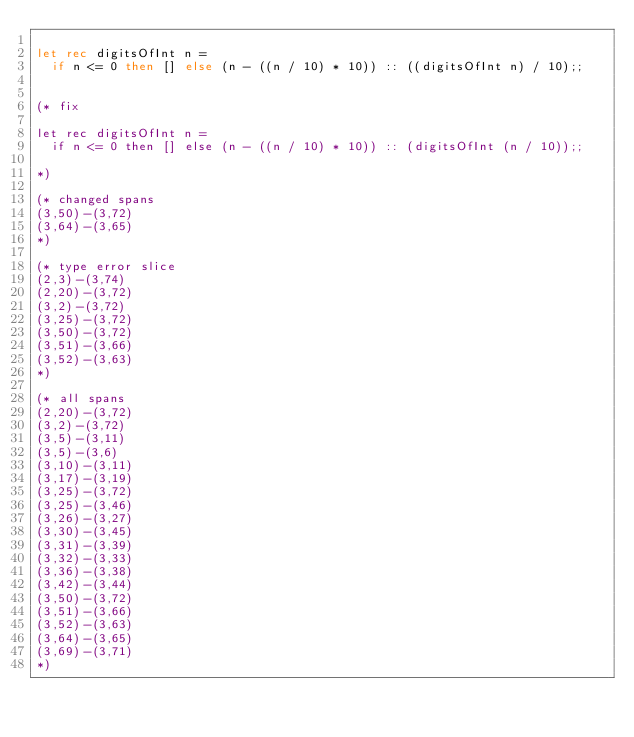<code> <loc_0><loc_0><loc_500><loc_500><_OCaml_>
let rec digitsOfInt n =
  if n <= 0 then [] else (n - ((n / 10) * 10)) :: ((digitsOfInt n) / 10);;


(* fix

let rec digitsOfInt n =
  if n <= 0 then [] else (n - ((n / 10) * 10)) :: (digitsOfInt (n / 10));;

*)

(* changed spans
(3,50)-(3,72)
(3,64)-(3,65)
*)

(* type error slice
(2,3)-(3,74)
(2,20)-(3,72)
(3,2)-(3,72)
(3,25)-(3,72)
(3,50)-(3,72)
(3,51)-(3,66)
(3,52)-(3,63)
*)

(* all spans
(2,20)-(3,72)
(3,2)-(3,72)
(3,5)-(3,11)
(3,5)-(3,6)
(3,10)-(3,11)
(3,17)-(3,19)
(3,25)-(3,72)
(3,25)-(3,46)
(3,26)-(3,27)
(3,30)-(3,45)
(3,31)-(3,39)
(3,32)-(3,33)
(3,36)-(3,38)
(3,42)-(3,44)
(3,50)-(3,72)
(3,51)-(3,66)
(3,52)-(3,63)
(3,64)-(3,65)
(3,69)-(3,71)
*)
</code> 